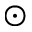Convert formula to latex. <formula><loc_0><loc_0><loc_500><loc_500>\odot</formula> 